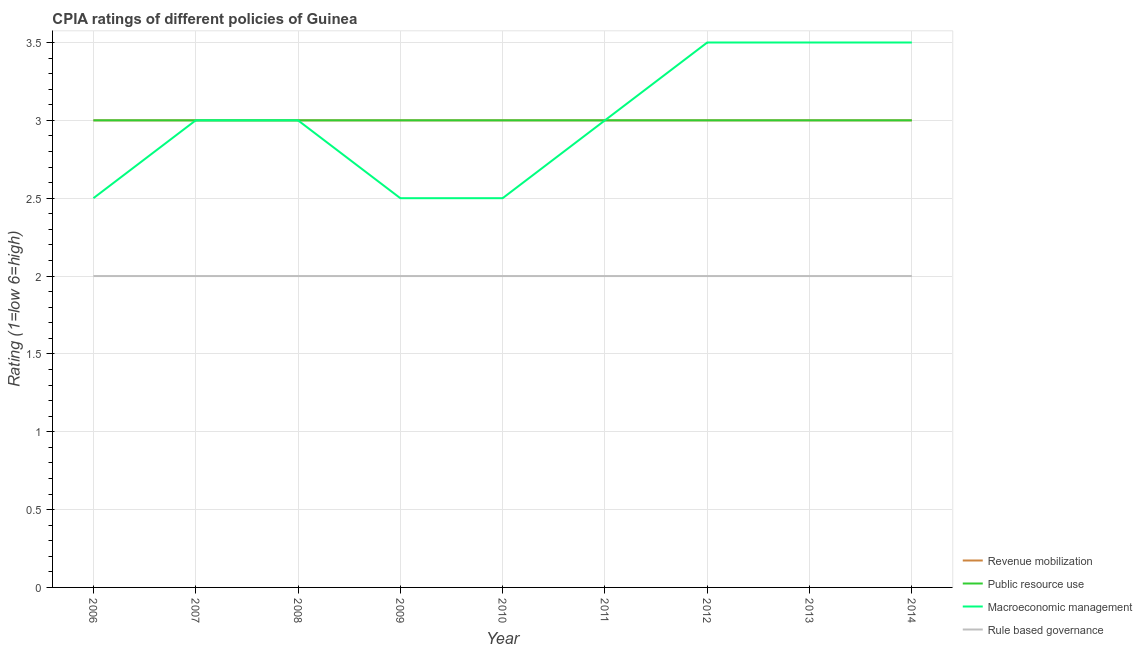Does the line corresponding to cpia rating of revenue mobilization intersect with the line corresponding to cpia rating of macroeconomic management?
Keep it short and to the point. Yes. What is the cpia rating of rule based governance in 2014?
Make the answer very short. 2. Across all years, what is the maximum cpia rating of rule based governance?
Give a very brief answer. 2. Across all years, what is the minimum cpia rating of revenue mobilization?
Make the answer very short. 3. In which year was the cpia rating of public resource use minimum?
Ensure brevity in your answer.  2006. What is the total cpia rating of revenue mobilization in the graph?
Offer a terse response. 27. What is the difference between the cpia rating of rule based governance in 2010 and the cpia rating of public resource use in 2008?
Provide a short and direct response. -1. What is the average cpia rating of rule based governance per year?
Provide a short and direct response. 2. In the year 2013, what is the difference between the cpia rating of macroeconomic management and cpia rating of public resource use?
Ensure brevity in your answer.  0.5. In how many years, is the cpia rating of public resource use greater than 1?
Provide a succinct answer. 9. What is the ratio of the cpia rating of revenue mobilization in 2012 to that in 2014?
Your answer should be very brief. 1. Is the difference between the cpia rating of revenue mobilization in 2011 and 2013 greater than the difference between the cpia rating of public resource use in 2011 and 2013?
Offer a very short reply. No. What is the difference between the highest and the second highest cpia rating of revenue mobilization?
Provide a succinct answer. 0. What is the difference between the highest and the lowest cpia rating of revenue mobilization?
Provide a succinct answer. 0. In how many years, is the cpia rating of macroeconomic management greater than the average cpia rating of macroeconomic management taken over all years?
Offer a very short reply. 3. Is the sum of the cpia rating of macroeconomic management in 2008 and 2010 greater than the maximum cpia rating of public resource use across all years?
Offer a very short reply. Yes. Does the cpia rating of rule based governance monotonically increase over the years?
Your answer should be compact. No. Is the cpia rating of rule based governance strictly greater than the cpia rating of macroeconomic management over the years?
Give a very brief answer. No. Is the cpia rating of revenue mobilization strictly less than the cpia rating of macroeconomic management over the years?
Make the answer very short. No. How many lines are there?
Your answer should be compact. 4. How many years are there in the graph?
Offer a terse response. 9. What is the difference between two consecutive major ticks on the Y-axis?
Offer a terse response. 0.5. Are the values on the major ticks of Y-axis written in scientific E-notation?
Offer a terse response. No. How many legend labels are there?
Keep it short and to the point. 4. How are the legend labels stacked?
Offer a very short reply. Vertical. What is the title of the graph?
Your response must be concise. CPIA ratings of different policies of Guinea. What is the Rating (1=low 6=high) in Revenue mobilization in 2006?
Your answer should be compact. 3. What is the Rating (1=low 6=high) in Rule based governance in 2006?
Your response must be concise. 2. What is the Rating (1=low 6=high) of Public resource use in 2007?
Your answer should be compact. 3. What is the Rating (1=low 6=high) of Rule based governance in 2007?
Your answer should be compact. 2. What is the Rating (1=low 6=high) in Revenue mobilization in 2008?
Make the answer very short. 3. What is the Rating (1=low 6=high) in Macroeconomic management in 2008?
Provide a succinct answer. 3. What is the Rating (1=low 6=high) of Rule based governance in 2008?
Your answer should be very brief. 2. What is the Rating (1=low 6=high) in Revenue mobilization in 2009?
Give a very brief answer. 3. What is the Rating (1=low 6=high) of Public resource use in 2009?
Provide a succinct answer. 3. What is the Rating (1=low 6=high) of Macroeconomic management in 2009?
Offer a very short reply. 2.5. What is the Rating (1=low 6=high) in Public resource use in 2011?
Give a very brief answer. 3. What is the Rating (1=low 6=high) in Rule based governance in 2011?
Make the answer very short. 2. What is the Rating (1=low 6=high) in Revenue mobilization in 2012?
Provide a succinct answer. 3. What is the Rating (1=low 6=high) of Public resource use in 2012?
Give a very brief answer. 3. What is the Rating (1=low 6=high) in Macroeconomic management in 2012?
Your response must be concise. 3.5. What is the Rating (1=low 6=high) of Rule based governance in 2012?
Offer a very short reply. 2. What is the Rating (1=low 6=high) in Revenue mobilization in 2013?
Your answer should be very brief. 3. What is the Rating (1=low 6=high) of Rule based governance in 2013?
Make the answer very short. 2. What is the Rating (1=low 6=high) in Macroeconomic management in 2014?
Offer a terse response. 3.5. What is the Rating (1=low 6=high) in Rule based governance in 2014?
Your answer should be very brief. 2. Across all years, what is the maximum Rating (1=low 6=high) in Public resource use?
Your answer should be compact. 3. Across all years, what is the maximum Rating (1=low 6=high) of Macroeconomic management?
Ensure brevity in your answer.  3.5. Across all years, what is the minimum Rating (1=low 6=high) of Revenue mobilization?
Keep it short and to the point. 3. Across all years, what is the minimum Rating (1=low 6=high) of Public resource use?
Your response must be concise. 3. What is the total Rating (1=low 6=high) in Public resource use in the graph?
Your answer should be very brief. 27. What is the total Rating (1=low 6=high) of Macroeconomic management in the graph?
Offer a very short reply. 27. What is the difference between the Rating (1=low 6=high) in Revenue mobilization in 2006 and that in 2007?
Your answer should be very brief. 0. What is the difference between the Rating (1=low 6=high) in Public resource use in 2006 and that in 2007?
Your response must be concise. 0. What is the difference between the Rating (1=low 6=high) in Rule based governance in 2006 and that in 2007?
Make the answer very short. 0. What is the difference between the Rating (1=low 6=high) in Macroeconomic management in 2006 and that in 2008?
Provide a succinct answer. -0.5. What is the difference between the Rating (1=low 6=high) of Revenue mobilization in 2006 and that in 2009?
Your answer should be very brief. 0. What is the difference between the Rating (1=low 6=high) in Public resource use in 2006 and that in 2009?
Make the answer very short. 0. What is the difference between the Rating (1=low 6=high) of Macroeconomic management in 2006 and that in 2009?
Provide a succinct answer. 0. What is the difference between the Rating (1=low 6=high) of Revenue mobilization in 2006 and that in 2010?
Ensure brevity in your answer.  0. What is the difference between the Rating (1=low 6=high) of Public resource use in 2006 and that in 2010?
Ensure brevity in your answer.  0. What is the difference between the Rating (1=low 6=high) of Macroeconomic management in 2006 and that in 2010?
Provide a short and direct response. 0. What is the difference between the Rating (1=low 6=high) in Rule based governance in 2006 and that in 2010?
Your answer should be compact. 0. What is the difference between the Rating (1=low 6=high) in Macroeconomic management in 2006 and that in 2011?
Your answer should be compact. -0.5. What is the difference between the Rating (1=low 6=high) of Rule based governance in 2006 and that in 2011?
Offer a very short reply. 0. What is the difference between the Rating (1=low 6=high) of Revenue mobilization in 2006 and that in 2012?
Provide a short and direct response. 0. What is the difference between the Rating (1=low 6=high) of Rule based governance in 2006 and that in 2012?
Keep it short and to the point. 0. What is the difference between the Rating (1=low 6=high) in Revenue mobilization in 2006 and that in 2013?
Keep it short and to the point. 0. What is the difference between the Rating (1=low 6=high) in Public resource use in 2006 and that in 2013?
Give a very brief answer. 0. What is the difference between the Rating (1=low 6=high) of Macroeconomic management in 2006 and that in 2013?
Make the answer very short. -1. What is the difference between the Rating (1=low 6=high) of Public resource use in 2006 and that in 2014?
Your answer should be very brief. 0. What is the difference between the Rating (1=low 6=high) in Macroeconomic management in 2006 and that in 2014?
Keep it short and to the point. -1. What is the difference between the Rating (1=low 6=high) in Rule based governance in 2006 and that in 2014?
Ensure brevity in your answer.  0. What is the difference between the Rating (1=low 6=high) of Public resource use in 2007 and that in 2008?
Your answer should be compact. 0. What is the difference between the Rating (1=low 6=high) in Public resource use in 2007 and that in 2009?
Your answer should be compact. 0. What is the difference between the Rating (1=low 6=high) in Macroeconomic management in 2007 and that in 2009?
Your answer should be very brief. 0.5. What is the difference between the Rating (1=low 6=high) in Revenue mobilization in 2007 and that in 2010?
Provide a short and direct response. 0. What is the difference between the Rating (1=low 6=high) of Macroeconomic management in 2007 and that in 2010?
Provide a short and direct response. 0.5. What is the difference between the Rating (1=low 6=high) of Macroeconomic management in 2007 and that in 2011?
Provide a short and direct response. 0. What is the difference between the Rating (1=low 6=high) in Rule based governance in 2007 and that in 2011?
Offer a very short reply. 0. What is the difference between the Rating (1=low 6=high) in Public resource use in 2007 and that in 2012?
Ensure brevity in your answer.  0. What is the difference between the Rating (1=low 6=high) in Rule based governance in 2007 and that in 2012?
Your answer should be compact. 0. What is the difference between the Rating (1=low 6=high) in Macroeconomic management in 2007 and that in 2013?
Your response must be concise. -0.5. What is the difference between the Rating (1=low 6=high) of Rule based governance in 2007 and that in 2013?
Your response must be concise. 0. What is the difference between the Rating (1=low 6=high) in Revenue mobilization in 2007 and that in 2014?
Provide a succinct answer. 0. What is the difference between the Rating (1=low 6=high) in Macroeconomic management in 2007 and that in 2014?
Keep it short and to the point. -0.5. What is the difference between the Rating (1=low 6=high) in Public resource use in 2008 and that in 2010?
Make the answer very short. 0. What is the difference between the Rating (1=low 6=high) in Revenue mobilization in 2008 and that in 2011?
Provide a short and direct response. 0. What is the difference between the Rating (1=low 6=high) of Macroeconomic management in 2008 and that in 2011?
Provide a short and direct response. 0. What is the difference between the Rating (1=low 6=high) in Rule based governance in 2008 and that in 2011?
Make the answer very short. 0. What is the difference between the Rating (1=low 6=high) in Revenue mobilization in 2008 and that in 2012?
Offer a very short reply. 0. What is the difference between the Rating (1=low 6=high) of Macroeconomic management in 2008 and that in 2012?
Keep it short and to the point. -0.5. What is the difference between the Rating (1=low 6=high) of Rule based governance in 2008 and that in 2012?
Keep it short and to the point. 0. What is the difference between the Rating (1=low 6=high) in Revenue mobilization in 2008 and that in 2013?
Your answer should be compact. 0. What is the difference between the Rating (1=low 6=high) in Public resource use in 2008 and that in 2014?
Offer a very short reply. 0. What is the difference between the Rating (1=low 6=high) in Macroeconomic management in 2008 and that in 2014?
Keep it short and to the point. -0.5. What is the difference between the Rating (1=low 6=high) in Rule based governance in 2008 and that in 2014?
Offer a very short reply. 0. What is the difference between the Rating (1=low 6=high) in Revenue mobilization in 2009 and that in 2010?
Keep it short and to the point. 0. What is the difference between the Rating (1=low 6=high) in Macroeconomic management in 2009 and that in 2010?
Your response must be concise. 0. What is the difference between the Rating (1=low 6=high) in Revenue mobilization in 2009 and that in 2011?
Offer a terse response. 0. What is the difference between the Rating (1=low 6=high) of Public resource use in 2009 and that in 2011?
Your answer should be compact. 0. What is the difference between the Rating (1=low 6=high) of Macroeconomic management in 2009 and that in 2011?
Your answer should be compact. -0.5. What is the difference between the Rating (1=low 6=high) of Public resource use in 2009 and that in 2012?
Ensure brevity in your answer.  0. What is the difference between the Rating (1=low 6=high) in Rule based governance in 2009 and that in 2012?
Ensure brevity in your answer.  0. What is the difference between the Rating (1=low 6=high) in Revenue mobilization in 2009 and that in 2013?
Offer a terse response. 0. What is the difference between the Rating (1=low 6=high) of Macroeconomic management in 2009 and that in 2013?
Offer a terse response. -1. What is the difference between the Rating (1=low 6=high) in Rule based governance in 2009 and that in 2013?
Make the answer very short. 0. What is the difference between the Rating (1=low 6=high) in Revenue mobilization in 2009 and that in 2014?
Your answer should be compact. 0. What is the difference between the Rating (1=low 6=high) in Public resource use in 2009 and that in 2014?
Keep it short and to the point. 0. What is the difference between the Rating (1=low 6=high) in Revenue mobilization in 2010 and that in 2011?
Make the answer very short. 0. What is the difference between the Rating (1=low 6=high) in Macroeconomic management in 2010 and that in 2011?
Your response must be concise. -0.5. What is the difference between the Rating (1=low 6=high) in Rule based governance in 2010 and that in 2011?
Your answer should be very brief. 0. What is the difference between the Rating (1=low 6=high) of Macroeconomic management in 2010 and that in 2012?
Your response must be concise. -1. What is the difference between the Rating (1=low 6=high) in Revenue mobilization in 2010 and that in 2013?
Offer a very short reply. 0. What is the difference between the Rating (1=low 6=high) in Macroeconomic management in 2010 and that in 2013?
Your answer should be very brief. -1. What is the difference between the Rating (1=low 6=high) of Rule based governance in 2010 and that in 2013?
Your response must be concise. 0. What is the difference between the Rating (1=low 6=high) of Revenue mobilization in 2010 and that in 2014?
Offer a very short reply. 0. What is the difference between the Rating (1=low 6=high) in Macroeconomic management in 2010 and that in 2014?
Your response must be concise. -1. What is the difference between the Rating (1=low 6=high) of Macroeconomic management in 2011 and that in 2012?
Give a very brief answer. -0.5. What is the difference between the Rating (1=low 6=high) in Rule based governance in 2011 and that in 2012?
Your answer should be very brief. 0. What is the difference between the Rating (1=low 6=high) of Public resource use in 2011 and that in 2013?
Give a very brief answer. 0. What is the difference between the Rating (1=low 6=high) in Rule based governance in 2011 and that in 2013?
Ensure brevity in your answer.  0. What is the difference between the Rating (1=low 6=high) in Revenue mobilization in 2011 and that in 2014?
Make the answer very short. 0. What is the difference between the Rating (1=low 6=high) of Public resource use in 2011 and that in 2014?
Make the answer very short. 0. What is the difference between the Rating (1=low 6=high) in Macroeconomic management in 2011 and that in 2014?
Give a very brief answer. -0.5. What is the difference between the Rating (1=low 6=high) in Rule based governance in 2011 and that in 2014?
Make the answer very short. 0. What is the difference between the Rating (1=low 6=high) in Revenue mobilization in 2012 and that in 2013?
Make the answer very short. 0. What is the difference between the Rating (1=low 6=high) in Public resource use in 2012 and that in 2013?
Provide a succinct answer. 0. What is the difference between the Rating (1=low 6=high) in Macroeconomic management in 2012 and that in 2013?
Provide a short and direct response. 0. What is the difference between the Rating (1=low 6=high) in Revenue mobilization in 2012 and that in 2014?
Ensure brevity in your answer.  0. What is the difference between the Rating (1=low 6=high) of Public resource use in 2012 and that in 2014?
Give a very brief answer. 0. What is the difference between the Rating (1=low 6=high) in Rule based governance in 2012 and that in 2014?
Offer a terse response. 0. What is the difference between the Rating (1=low 6=high) of Revenue mobilization in 2013 and that in 2014?
Offer a terse response. 0. What is the difference between the Rating (1=low 6=high) of Macroeconomic management in 2013 and that in 2014?
Your answer should be compact. 0. What is the difference between the Rating (1=low 6=high) of Rule based governance in 2013 and that in 2014?
Your answer should be very brief. 0. What is the difference between the Rating (1=low 6=high) of Revenue mobilization in 2006 and the Rating (1=low 6=high) of Rule based governance in 2007?
Your answer should be compact. 1. What is the difference between the Rating (1=low 6=high) in Public resource use in 2006 and the Rating (1=low 6=high) in Rule based governance in 2007?
Your answer should be very brief. 1. What is the difference between the Rating (1=low 6=high) of Macroeconomic management in 2006 and the Rating (1=low 6=high) of Rule based governance in 2007?
Your response must be concise. 0.5. What is the difference between the Rating (1=low 6=high) of Revenue mobilization in 2006 and the Rating (1=low 6=high) of Macroeconomic management in 2008?
Ensure brevity in your answer.  0. What is the difference between the Rating (1=low 6=high) in Revenue mobilization in 2006 and the Rating (1=low 6=high) in Rule based governance in 2008?
Provide a short and direct response. 1. What is the difference between the Rating (1=low 6=high) in Public resource use in 2006 and the Rating (1=low 6=high) in Rule based governance in 2008?
Provide a short and direct response. 1. What is the difference between the Rating (1=low 6=high) of Revenue mobilization in 2006 and the Rating (1=low 6=high) of Public resource use in 2009?
Ensure brevity in your answer.  0. What is the difference between the Rating (1=low 6=high) of Revenue mobilization in 2006 and the Rating (1=low 6=high) of Macroeconomic management in 2009?
Provide a succinct answer. 0.5. What is the difference between the Rating (1=low 6=high) of Revenue mobilization in 2006 and the Rating (1=low 6=high) of Rule based governance in 2009?
Provide a succinct answer. 1. What is the difference between the Rating (1=low 6=high) in Public resource use in 2006 and the Rating (1=low 6=high) in Rule based governance in 2009?
Ensure brevity in your answer.  1. What is the difference between the Rating (1=low 6=high) of Revenue mobilization in 2006 and the Rating (1=low 6=high) of Public resource use in 2010?
Make the answer very short. 0. What is the difference between the Rating (1=low 6=high) of Revenue mobilization in 2006 and the Rating (1=low 6=high) of Rule based governance in 2010?
Make the answer very short. 1. What is the difference between the Rating (1=low 6=high) of Macroeconomic management in 2006 and the Rating (1=low 6=high) of Rule based governance in 2010?
Provide a succinct answer. 0.5. What is the difference between the Rating (1=low 6=high) in Revenue mobilization in 2006 and the Rating (1=low 6=high) in Public resource use in 2011?
Your response must be concise. 0. What is the difference between the Rating (1=low 6=high) in Revenue mobilization in 2006 and the Rating (1=low 6=high) in Macroeconomic management in 2011?
Ensure brevity in your answer.  0. What is the difference between the Rating (1=low 6=high) in Public resource use in 2006 and the Rating (1=low 6=high) in Rule based governance in 2011?
Offer a very short reply. 1. What is the difference between the Rating (1=low 6=high) of Macroeconomic management in 2006 and the Rating (1=low 6=high) of Rule based governance in 2011?
Your response must be concise. 0.5. What is the difference between the Rating (1=low 6=high) in Revenue mobilization in 2006 and the Rating (1=low 6=high) in Macroeconomic management in 2012?
Ensure brevity in your answer.  -0.5. What is the difference between the Rating (1=low 6=high) in Revenue mobilization in 2006 and the Rating (1=low 6=high) in Rule based governance in 2012?
Provide a short and direct response. 1. What is the difference between the Rating (1=low 6=high) of Public resource use in 2006 and the Rating (1=low 6=high) of Macroeconomic management in 2012?
Give a very brief answer. -0.5. What is the difference between the Rating (1=low 6=high) of Macroeconomic management in 2006 and the Rating (1=low 6=high) of Rule based governance in 2012?
Ensure brevity in your answer.  0.5. What is the difference between the Rating (1=low 6=high) in Revenue mobilization in 2006 and the Rating (1=low 6=high) in Public resource use in 2013?
Provide a succinct answer. 0. What is the difference between the Rating (1=low 6=high) of Macroeconomic management in 2006 and the Rating (1=low 6=high) of Rule based governance in 2013?
Your answer should be compact. 0.5. What is the difference between the Rating (1=low 6=high) in Revenue mobilization in 2006 and the Rating (1=low 6=high) in Public resource use in 2014?
Make the answer very short. 0. What is the difference between the Rating (1=low 6=high) of Public resource use in 2006 and the Rating (1=low 6=high) of Rule based governance in 2014?
Make the answer very short. 1. What is the difference between the Rating (1=low 6=high) of Revenue mobilization in 2007 and the Rating (1=low 6=high) of Macroeconomic management in 2008?
Give a very brief answer. 0. What is the difference between the Rating (1=low 6=high) of Revenue mobilization in 2007 and the Rating (1=low 6=high) of Rule based governance in 2008?
Make the answer very short. 1. What is the difference between the Rating (1=low 6=high) in Public resource use in 2007 and the Rating (1=low 6=high) in Rule based governance in 2008?
Your answer should be very brief. 1. What is the difference between the Rating (1=low 6=high) in Macroeconomic management in 2007 and the Rating (1=low 6=high) in Rule based governance in 2008?
Give a very brief answer. 1. What is the difference between the Rating (1=low 6=high) in Revenue mobilization in 2007 and the Rating (1=low 6=high) in Rule based governance in 2009?
Provide a short and direct response. 1. What is the difference between the Rating (1=low 6=high) of Public resource use in 2007 and the Rating (1=low 6=high) of Macroeconomic management in 2009?
Give a very brief answer. 0.5. What is the difference between the Rating (1=low 6=high) in Macroeconomic management in 2007 and the Rating (1=low 6=high) in Rule based governance in 2009?
Offer a very short reply. 1. What is the difference between the Rating (1=low 6=high) of Revenue mobilization in 2007 and the Rating (1=low 6=high) of Rule based governance in 2010?
Your answer should be very brief. 1. What is the difference between the Rating (1=low 6=high) of Public resource use in 2007 and the Rating (1=low 6=high) of Macroeconomic management in 2010?
Ensure brevity in your answer.  0.5. What is the difference between the Rating (1=low 6=high) of Public resource use in 2007 and the Rating (1=low 6=high) of Rule based governance in 2010?
Offer a terse response. 1. What is the difference between the Rating (1=low 6=high) in Macroeconomic management in 2007 and the Rating (1=low 6=high) in Rule based governance in 2010?
Your answer should be compact. 1. What is the difference between the Rating (1=low 6=high) of Revenue mobilization in 2007 and the Rating (1=low 6=high) of Public resource use in 2011?
Your answer should be very brief. 0. What is the difference between the Rating (1=low 6=high) in Revenue mobilization in 2007 and the Rating (1=low 6=high) in Macroeconomic management in 2011?
Offer a terse response. 0. What is the difference between the Rating (1=low 6=high) in Macroeconomic management in 2007 and the Rating (1=low 6=high) in Rule based governance in 2011?
Ensure brevity in your answer.  1. What is the difference between the Rating (1=low 6=high) of Public resource use in 2007 and the Rating (1=low 6=high) of Macroeconomic management in 2012?
Ensure brevity in your answer.  -0.5. What is the difference between the Rating (1=low 6=high) in Macroeconomic management in 2007 and the Rating (1=low 6=high) in Rule based governance in 2012?
Offer a very short reply. 1. What is the difference between the Rating (1=low 6=high) of Revenue mobilization in 2007 and the Rating (1=low 6=high) of Macroeconomic management in 2013?
Ensure brevity in your answer.  -0.5. What is the difference between the Rating (1=low 6=high) of Revenue mobilization in 2007 and the Rating (1=low 6=high) of Rule based governance in 2013?
Your answer should be compact. 1. What is the difference between the Rating (1=low 6=high) in Public resource use in 2007 and the Rating (1=low 6=high) in Macroeconomic management in 2013?
Make the answer very short. -0.5. What is the difference between the Rating (1=low 6=high) of Revenue mobilization in 2007 and the Rating (1=low 6=high) of Macroeconomic management in 2014?
Provide a short and direct response. -0.5. What is the difference between the Rating (1=low 6=high) in Revenue mobilization in 2007 and the Rating (1=low 6=high) in Rule based governance in 2014?
Ensure brevity in your answer.  1. What is the difference between the Rating (1=low 6=high) of Public resource use in 2007 and the Rating (1=low 6=high) of Macroeconomic management in 2014?
Offer a terse response. -0.5. What is the difference between the Rating (1=low 6=high) of Revenue mobilization in 2008 and the Rating (1=low 6=high) of Macroeconomic management in 2009?
Provide a succinct answer. 0.5. What is the difference between the Rating (1=low 6=high) in Revenue mobilization in 2008 and the Rating (1=low 6=high) in Rule based governance in 2009?
Ensure brevity in your answer.  1. What is the difference between the Rating (1=low 6=high) of Public resource use in 2008 and the Rating (1=low 6=high) of Rule based governance in 2009?
Keep it short and to the point. 1. What is the difference between the Rating (1=low 6=high) of Macroeconomic management in 2008 and the Rating (1=low 6=high) of Rule based governance in 2009?
Keep it short and to the point. 1. What is the difference between the Rating (1=low 6=high) of Revenue mobilization in 2008 and the Rating (1=low 6=high) of Rule based governance in 2010?
Give a very brief answer. 1. What is the difference between the Rating (1=low 6=high) of Public resource use in 2008 and the Rating (1=low 6=high) of Rule based governance in 2010?
Keep it short and to the point. 1. What is the difference between the Rating (1=low 6=high) in Revenue mobilization in 2008 and the Rating (1=low 6=high) in Public resource use in 2011?
Your response must be concise. 0. What is the difference between the Rating (1=low 6=high) in Revenue mobilization in 2008 and the Rating (1=low 6=high) in Rule based governance in 2011?
Ensure brevity in your answer.  1. What is the difference between the Rating (1=low 6=high) in Public resource use in 2008 and the Rating (1=low 6=high) in Macroeconomic management in 2011?
Make the answer very short. 0. What is the difference between the Rating (1=low 6=high) of Public resource use in 2008 and the Rating (1=low 6=high) of Rule based governance in 2011?
Your answer should be very brief. 1. What is the difference between the Rating (1=low 6=high) in Revenue mobilization in 2008 and the Rating (1=low 6=high) in Public resource use in 2012?
Provide a succinct answer. 0. What is the difference between the Rating (1=low 6=high) in Revenue mobilization in 2008 and the Rating (1=low 6=high) in Macroeconomic management in 2012?
Your response must be concise. -0.5. What is the difference between the Rating (1=low 6=high) in Revenue mobilization in 2008 and the Rating (1=low 6=high) in Rule based governance in 2012?
Your answer should be very brief. 1. What is the difference between the Rating (1=low 6=high) of Public resource use in 2008 and the Rating (1=low 6=high) of Rule based governance in 2012?
Provide a short and direct response. 1. What is the difference between the Rating (1=low 6=high) of Macroeconomic management in 2008 and the Rating (1=low 6=high) of Rule based governance in 2012?
Ensure brevity in your answer.  1. What is the difference between the Rating (1=low 6=high) in Public resource use in 2008 and the Rating (1=low 6=high) in Macroeconomic management in 2013?
Give a very brief answer. -0.5. What is the difference between the Rating (1=low 6=high) in Revenue mobilization in 2008 and the Rating (1=low 6=high) in Macroeconomic management in 2014?
Give a very brief answer. -0.5. What is the difference between the Rating (1=low 6=high) of Public resource use in 2008 and the Rating (1=low 6=high) of Macroeconomic management in 2014?
Your response must be concise. -0.5. What is the difference between the Rating (1=low 6=high) in Public resource use in 2008 and the Rating (1=low 6=high) in Rule based governance in 2014?
Make the answer very short. 1. What is the difference between the Rating (1=low 6=high) in Revenue mobilization in 2009 and the Rating (1=low 6=high) in Public resource use in 2010?
Ensure brevity in your answer.  0. What is the difference between the Rating (1=low 6=high) in Revenue mobilization in 2009 and the Rating (1=low 6=high) in Macroeconomic management in 2010?
Make the answer very short. 0.5. What is the difference between the Rating (1=low 6=high) of Public resource use in 2009 and the Rating (1=low 6=high) of Rule based governance in 2010?
Keep it short and to the point. 1. What is the difference between the Rating (1=low 6=high) in Revenue mobilization in 2009 and the Rating (1=low 6=high) in Public resource use in 2011?
Keep it short and to the point. 0. What is the difference between the Rating (1=low 6=high) in Revenue mobilization in 2009 and the Rating (1=low 6=high) in Macroeconomic management in 2011?
Your answer should be compact. 0. What is the difference between the Rating (1=low 6=high) in Macroeconomic management in 2009 and the Rating (1=low 6=high) in Rule based governance in 2011?
Provide a short and direct response. 0.5. What is the difference between the Rating (1=low 6=high) of Revenue mobilization in 2009 and the Rating (1=low 6=high) of Rule based governance in 2012?
Offer a terse response. 1. What is the difference between the Rating (1=low 6=high) in Macroeconomic management in 2009 and the Rating (1=low 6=high) in Rule based governance in 2012?
Provide a succinct answer. 0.5. What is the difference between the Rating (1=low 6=high) of Revenue mobilization in 2009 and the Rating (1=low 6=high) of Macroeconomic management in 2013?
Offer a terse response. -0.5. What is the difference between the Rating (1=low 6=high) in Revenue mobilization in 2009 and the Rating (1=low 6=high) in Rule based governance in 2013?
Make the answer very short. 1. What is the difference between the Rating (1=low 6=high) of Public resource use in 2009 and the Rating (1=low 6=high) of Macroeconomic management in 2013?
Your answer should be compact. -0.5. What is the difference between the Rating (1=low 6=high) of Public resource use in 2009 and the Rating (1=low 6=high) of Rule based governance in 2013?
Keep it short and to the point. 1. What is the difference between the Rating (1=low 6=high) of Macroeconomic management in 2009 and the Rating (1=low 6=high) of Rule based governance in 2013?
Provide a succinct answer. 0.5. What is the difference between the Rating (1=low 6=high) in Revenue mobilization in 2009 and the Rating (1=low 6=high) in Public resource use in 2014?
Offer a very short reply. 0. What is the difference between the Rating (1=low 6=high) in Revenue mobilization in 2009 and the Rating (1=low 6=high) in Macroeconomic management in 2014?
Your response must be concise. -0.5. What is the difference between the Rating (1=low 6=high) of Revenue mobilization in 2009 and the Rating (1=low 6=high) of Rule based governance in 2014?
Provide a short and direct response. 1. What is the difference between the Rating (1=low 6=high) of Public resource use in 2009 and the Rating (1=low 6=high) of Macroeconomic management in 2014?
Offer a terse response. -0.5. What is the difference between the Rating (1=low 6=high) in Public resource use in 2009 and the Rating (1=low 6=high) in Rule based governance in 2014?
Provide a succinct answer. 1. What is the difference between the Rating (1=low 6=high) in Macroeconomic management in 2009 and the Rating (1=low 6=high) in Rule based governance in 2014?
Keep it short and to the point. 0.5. What is the difference between the Rating (1=low 6=high) of Public resource use in 2010 and the Rating (1=low 6=high) of Rule based governance in 2011?
Offer a terse response. 1. What is the difference between the Rating (1=low 6=high) of Macroeconomic management in 2010 and the Rating (1=low 6=high) of Rule based governance in 2012?
Make the answer very short. 0.5. What is the difference between the Rating (1=low 6=high) of Revenue mobilization in 2010 and the Rating (1=low 6=high) of Macroeconomic management in 2013?
Make the answer very short. -0.5. What is the difference between the Rating (1=low 6=high) of Revenue mobilization in 2010 and the Rating (1=low 6=high) of Rule based governance in 2013?
Offer a terse response. 1. What is the difference between the Rating (1=low 6=high) of Public resource use in 2010 and the Rating (1=low 6=high) of Macroeconomic management in 2013?
Provide a succinct answer. -0.5. What is the difference between the Rating (1=low 6=high) in Public resource use in 2010 and the Rating (1=low 6=high) in Rule based governance in 2013?
Provide a short and direct response. 1. What is the difference between the Rating (1=low 6=high) in Revenue mobilization in 2010 and the Rating (1=low 6=high) in Macroeconomic management in 2014?
Provide a succinct answer. -0.5. What is the difference between the Rating (1=low 6=high) of Revenue mobilization in 2010 and the Rating (1=low 6=high) of Rule based governance in 2014?
Provide a short and direct response. 1. What is the difference between the Rating (1=low 6=high) in Public resource use in 2010 and the Rating (1=low 6=high) in Macroeconomic management in 2014?
Your answer should be compact. -0.5. What is the difference between the Rating (1=low 6=high) of Macroeconomic management in 2010 and the Rating (1=low 6=high) of Rule based governance in 2014?
Offer a terse response. 0.5. What is the difference between the Rating (1=low 6=high) of Revenue mobilization in 2011 and the Rating (1=low 6=high) of Public resource use in 2012?
Your answer should be very brief. 0. What is the difference between the Rating (1=low 6=high) in Revenue mobilization in 2011 and the Rating (1=low 6=high) in Macroeconomic management in 2012?
Offer a very short reply. -0.5. What is the difference between the Rating (1=low 6=high) in Public resource use in 2011 and the Rating (1=low 6=high) in Rule based governance in 2012?
Provide a succinct answer. 1. What is the difference between the Rating (1=low 6=high) of Public resource use in 2011 and the Rating (1=low 6=high) of Macroeconomic management in 2013?
Provide a succinct answer. -0.5. What is the difference between the Rating (1=low 6=high) of Public resource use in 2011 and the Rating (1=low 6=high) of Rule based governance in 2013?
Offer a very short reply. 1. What is the difference between the Rating (1=low 6=high) in Revenue mobilization in 2011 and the Rating (1=low 6=high) in Public resource use in 2014?
Make the answer very short. 0. What is the difference between the Rating (1=low 6=high) in Revenue mobilization in 2011 and the Rating (1=low 6=high) in Rule based governance in 2014?
Your response must be concise. 1. What is the difference between the Rating (1=low 6=high) of Public resource use in 2011 and the Rating (1=low 6=high) of Macroeconomic management in 2014?
Your answer should be compact. -0.5. What is the difference between the Rating (1=low 6=high) of Macroeconomic management in 2011 and the Rating (1=low 6=high) of Rule based governance in 2014?
Give a very brief answer. 1. What is the difference between the Rating (1=low 6=high) in Revenue mobilization in 2012 and the Rating (1=low 6=high) in Public resource use in 2013?
Provide a succinct answer. 0. What is the difference between the Rating (1=low 6=high) of Revenue mobilization in 2012 and the Rating (1=low 6=high) of Macroeconomic management in 2013?
Make the answer very short. -0.5. What is the difference between the Rating (1=low 6=high) of Macroeconomic management in 2012 and the Rating (1=low 6=high) of Rule based governance in 2014?
Ensure brevity in your answer.  1.5. What is the difference between the Rating (1=low 6=high) of Revenue mobilization in 2013 and the Rating (1=low 6=high) of Macroeconomic management in 2014?
Your answer should be compact. -0.5. What is the difference between the Rating (1=low 6=high) in Revenue mobilization in 2013 and the Rating (1=low 6=high) in Rule based governance in 2014?
Give a very brief answer. 1. What is the difference between the Rating (1=low 6=high) in Macroeconomic management in 2013 and the Rating (1=low 6=high) in Rule based governance in 2014?
Make the answer very short. 1.5. What is the average Rating (1=low 6=high) in Rule based governance per year?
Give a very brief answer. 2. In the year 2006, what is the difference between the Rating (1=low 6=high) of Revenue mobilization and Rating (1=low 6=high) of Rule based governance?
Offer a terse response. 1. In the year 2006, what is the difference between the Rating (1=low 6=high) in Public resource use and Rating (1=low 6=high) in Macroeconomic management?
Offer a terse response. 0.5. In the year 2007, what is the difference between the Rating (1=low 6=high) of Revenue mobilization and Rating (1=low 6=high) of Public resource use?
Give a very brief answer. 0. In the year 2007, what is the difference between the Rating (1=low 6=high) of Revenue mobilization and Rating (1=low 6=high) of Rule based governance?
Your response must be concise. 1. In the year 2007, what is the difference between the Rating (1=low 6=high) in Public resource use and Rating (1=low 6=high) in Rule based governance?
Make the answer very short. 1. In the year 2008, what is the difference between the Rating (1=low 6=high) in Revenue mobilization and Rating (1=low 6=high) in Macroeconomic management?
Offer a very short reply. 0. In the year 2008, what is the difference between the Rating (1=low 6=high) of Revenue mobilization and Rating (1=low 6=high) of Rule based governance?
Offer a very short reply. 1. In the year 2008, what is the difference between the Rating (1=low 6=high) in Macroeconomic management and Rating (1=low 6=high) in Rule based governance?
Offer a very short reply. 1. In the year 2009, what is the difference between the Rating (1=low 6=high) in Revenue mobilization and Rating (1=low 6=high) in Macroeconomic management?
Provide a short and direct response. 0.5. In the year 2010, what is the difference between the Rating (1=low 6=high) in Revenue mobilization and Rating (1=low 6=high) in Public resource use?
Make the answer very short. 0. In the year 2010, what is the difference between the Rating (1=low 6=high) of Revenue mobilization and Rating (1=low 6=high) of Macroeconomic management?
Provide a succinct answer. 0.5. In the year 2010, what is the difference between the Rating (1=low 6=high) in Revenue mobilization and Rating (1=low 6=high) in Rule based governance?
Give a very brief answer. 1. In the year 2010, what is the difference between the Rating (1=low 6=high) of Public resource use and Rating (1=low 6=high) of Macroeconomic management?
Offer a terse response. 0.5. In the year 2011, what is the difference between the Rating (1=low 6=high) of Revenue mobilization and Rating (1=low 6=high) of Public resource use?
Your response must be concise. 0. In the year 2011, what is the difference between the Rating (1=low 6=high) of Revenue mobilization and Rating (1=low 6=high) of Macroeconomic management?
Offer a terse response. 0. In the year 2011, what is the difference between the Rating (1=low 6=high) in Public resource use and Rating (1=low 6=high) in Macroeconomic management?
Offer a very short reply. 0. In the year 2011, what is the difference between the Rating (1=low 6=high) in Public resource use and Rating (1=low 6=high) in Rule based governance?
Make the answer very short. 1. In the year 2011, what is the difference between the Rating (1=low 6=high) of Macroeconomic management and Rating (1=low 6=high) of Rule based governance?
Your answer should be very brief. 1. In the year 2012, what is the difference between the Rating (1=low 6=high) in Revenue mobilization and Rating (1=low 6=high) in Public resource use?
Provide a short and direct response. 0. In the year 2012, what is the difference between the Rating (1=low 6=high) of Revenue mobilization and Rating (1=low 6=high) of Macroeconomic management?
Provide a succinct answer. -0.5. In the year 2012, what is the difference between the Rating (1=low 6=high) of Public resource use and Rating (1=low 6=high) of Rule based governance?
Give a very brief answer. 1. In the year 2013, what is the difference between the Rating (1=low 6=high) in Revenue mobilization and Rating (1=low 6=high) in Macroeconomic management?
Your answer should be very brief. -0.5. In the year 2013, what is the difference between the Rating (1=low 6=high) in Public resource use and Rating (1=low 6=high) in Macroeconomic management?
Offer a very short reply. -0.5. In the year 2013, what is the difference between the Rating (1=low 6=high) in Public resource use and Rating (1=low 6=high) in Rule based governance?
Your answer should be very brief. 1. In the year 2013, what is the difference between the Rating (1=low 6=high) in Macroeconomic management and Rating (1=low 6=high) in Rule based governance?
Keep it short and to the point. 1.5. In the year 2014, what is the difference between the Rating (1=low 6=high) in Macroeconomic management and Rating (1=low 6=high) in Rule based governance?
Make the answer very short. 1.5. What is the ratio of the Rating (1=low 6=high) of Public resource use in 2006 to that in 2007?
Offer a very short reply. 1. What is the ratio of the Rating (1=low 6=high) of Macroeconomic management in 2006 to that in 2007?
Provide a short and direct response. 0.83. What is the ratio of the Rating (1=low 6=high) in Rule based governance in 2006 to that in 2007?
Keep it short and to the point. 1. What is the ratio of the Rating (1=low 6=high) of Revenue mobilization in 2006 to that in 2008?
Offer a very short reply. 1. What is the ratio of the Rating (1=low 6=high) of Macroeconomic management in 2006 to that in 2008?
Make the answer very short. 0.83. What is the ratio of the Rating (1=low 6=high) in Rule based governance in 2006 to that in 2008?
Your answer should be compact. 1. What is the ratio of the Rating (1=low 6=high) of Macroeconomic management in 2006 to that in 2009?
Your answer should be very brief. 1. What is the ratio of the Rating (1=low 6=high) of Revenue mobilization in 2006 to that in 2010?
Provide a short and direct response. 1. What is the ratio of the Rating (1=low 6=high) of Macroeconomic management in 2006 to that in 2010?
Your answer should be very brief. 1. What is the ratio of the Rating (1=low 6=high) of Rule based governance in 2006 to that in 2010?
Your answer should be compact. 1. What is the ratio of the Rating (1=low 6=high) of Revenue mobilization in 2006 to that in 2011?
Make the answer very short. 1. What is the ratio of the Rating (1=low 6=high) of Macroeconomic management in 2006 to that in 2011?
Provide a succinct answer. 0.83. What is the ratio of the Rating (1=low 6=high) of Rule based governance in 2006 to that in 2011?
Provide a succinct answer. 1. What is the ratio of the Rating (1=low 6=high) of Revenue mobilization in 2006 to that in 2012?
Provide a succinct answer. 1. What is the ratio of the Rating (1=low 6=high) of Macroeconomic management in 2006 to that in 2012?
Your answer should be compact. 0.71. What is the ratio of the Rating (1=low 6=high) in Rule based governance in 2006 to that in 2012?
Keep it short and to the point. 1. What is the ratio of the Rating (1=low 6=high) of Public resource use in 2006 to that in 2013?
Offer a terse response. 1. What is the ratio of the Rating (1=low 6=high) of Macroeconomic management in 2006 to that in 2013?
Your answer should be very brief. 0.71. What is the ratio of the Rating (1=low 6=high) in Revenue mobilization in 2006 to that in 2014?
Your answer should be compact. 1. What is the ratio of the Rating (1=low 6=high) of Macroeconomic management in 2007 to that in 2008?
Offer a terse response. 1. What is the ratio of the Rating (1=low 6=high) in Revenue mobilization in 2007 to that in 2009?
Provide a succinct answer. 1. What is the ratio of the Rating (1=low 6=high) in Public resource use in 2007 to that in 2009?
Offer a terse response. 1. What is the ratio of the Rating (1=low 6=high) of Macroeconomic management in 2007 to that in 2010?
Make the answer very short. 1.2. What is the ratio of the Rating (1=low 6=high) in Rule based governance in 2007 to that in 2010?
Make the answer very short. 1. What is the ratio of the Rating (1=low 6=high) in Public resource use in 2007 to that in 2011?
Offer a very short reply. 1. What is the ratio of the Rating (1=low 6=high) of Public resource use in 2007 to that in 2012?
Your answer should be very brief. 1. What is the ratio of the Rating (1=low 6=high) of Rule based governance in 2007 to that in 2012?
Provide a short and direct response. 1. What is the ratio of the Rating (1=low 6=high) in Public resource use in 2007 to that in 2013?
Provide a succinct answer. 1. What is the ratio of the Rating (1=low 6=high) in Macroeconomic management in 2007 to that in 2013?
Your answer should be very brief. 0.86. What is the ratio of the Rating (1=low 6=high) of Revenue mobilization in 2007 to that in 2014?
Provide a succinct answer. 1. What is the ratio of the Rating (1=low 6=high) of Revenue mobilization in 2008 to that in 2009?
Make the answer very short. 1. What is the ratio of the Rating (1=low 6=high) in Public resource use in 2008 to that in 2009?
Ensure brevity in your answer.  1. What is the ratio of the Rating (1=low 6=high) of Macroeconomic management in 2008 to that in 2009?
Provide a succinct answer. 1.2. What is the ratio of the Rating (1=low 6=high) of Revenue mobilization in 2008 to that in 2010?
Your answer should be compact. 1. What is the ratio of the Rating (1=low 6=high) of Revenue mobilization in 2008 to that in 2011?
Offer a terse response. 1. What is the ratio of the Rating (1=low 6=high) in Public resource use in 2008 to that in 2011?
Keep it short and to the point. 1. What is the ratio of the Rating (1=low 6=high) in Macroeconomic management in 2008 to that in 2011?
Provide a short and direct response. 1. What is the ratio of the Rating (1=low 6=high) in Rule based governance in 2008 to that in 2011?
Give a very brief answer. 1. What is the ratio of the Rating (1=low 6=high) of Revenue mobilization in 2008 to that in 2012?
Make the answer very short. 1. What is the ratio of the Rating (1=low 6=high) of Public resource use in 2008 to that in 2012?
Your answer should be compact. 1. What is the ratio of the Rating (1=low 6=high) of Macroeconomic management in 2008 to that in 2012?
Provide a short and direct response. 0.86. What is the ratio of the Rating (1=low 6=high) of Rule based governance in 2008 to that in 2012?
Provide a short and direct response. 1. What is the ratio of the Rating (1=low 6=high) in Public resource use in 2008 to that in 2013?
Ensure brevity in your answer.  1. What is the ratio of the Rating (1=low 6=high) in Macroeconomic management in 2008 to that in 2013?
Your response must be concise. 0.86. What is the ratio of the Rating (1=low 6=high) of Rule based governance in 2008 to that in 2013?
Your answer should be compact. 1. What is the ratio of the Rating (1=low 6=high) in Revenue mobilization in 2008 to that in 2014?
Make the answer very short. 1. What is the ratio of the Rating (1=low 6=high) in Public resource use in 2008 to that in 2014?
Give a very brief answer. 1. What is the ratio of the Rating (1=low 6=high) in Revenue mobilization in 2009 to that in 2010?
Your response must be concise. 1. What is the ratio of the Rating (1=low 6=high) of Macroeconomic management in 2009 to that in 2011?
Your answer should be very brief. 0.83. What is the ratio of the Rating (1=low 6=high) of Rule based governance in 2009 to that in 2011?
Give a very brief answer. 1. What is the ratio of the Rating (1=low 6=high) in Public resource use in 2009 to that in 2012?
Give a very brief answer. 1. What is the ratio of the Rating (1=low 6=high) in Macroeconomic management in 2009 to that in 2012?
Ensure brevity in your answer.  0.71. What is the ratio of the Rating (1=low 6=high) of Rule based governance in 2009 to that in 2012?
Ensure brevity in your answer.  1. What is the ratio of the Rating (1=low 6=high) in Revenue mobilization in 2009 to that in 2014?
Your answer should be very brief. 1. What is the ratio of the Rating (1=low 6=high) in Public resource use in 2009 to that in 2014?
Keep it short and to the point. 1. What is the ratio of the Rating (1=low 6=high) in Revenue mobilization in 2010 to that in 2011?
Provide a short and direct response. 1. What is the ratio of the Rating (1=low 6=high) in Public resource use in 2010 to that in 2011?
Give a very brief answer. 1. What is the ratio of the Rating (1=low 6=high) in Revenue mobilization in 2010 to that in 2012?
Your answer should be compact. 1. What is the ratio of the Rating (1=low 6=high) of Public resource use in 2010 to that in 2013?
Offer a very short reply. 1. What is the ratio of the Rating (1=low 6=high) of Revenue mobilization in 2010 to that in 2014?
Your answer should be compact. 1. What is the ratio of the Rating (1=low 6=high) in Rule based governance in 2010 to that in 2014?
Offer a terse response. 1. What is the ratio of the Rating (1=low 6=high) of Revenue mobilization in 2011 to that in 2012?
Offer a terse response. 1. What is the ratio of the Rating (1=low 6=high) in Public resource use in 2011 to that in 2012?
Make the answer very short. 1. What is the ratio of the Rating (1=low 6=high) in Macroeconomic management in 2011 to that in 2012?
Offer a very short reply. 0.86. What is the ratio of the Rating (1=low 6=high) in Revenue mobilization in 2011 to that in 2013?
Your answer should be compact. 1. What is the ratio of the Rating (1=low 6=high) of Macroeconomic management in 2011 to that in 2013?
Offer a very short reply. 0.86. What is the ratio of the Rating (1=low 6=high) in Rule based governance in 2011 to that in 2013?
Make the answer very short. 1. What is the ratio of the Rating (1=low 6=high) of Macroeconomic management in 2011 to that in 2014?
Your answer should be compact. 0.86. What is the ratio of the Rating (1=low 6=high) of Rule based governance in 2011 to that in 2014?
Your response must be concise. 1. What is the ratio of the Rating (1=low 6=high) of Revenue mobilization in 2012 to that in 2013?
Offer a very short reply. 1. What is the ratio of the Rating (1=low 6=high) in Public resource use in 2012 to that in 2013?
Ensure brevity in your answer.  1. What is the ratio of the Rating (1=low 6=high) of Macroeconomic management in 2012 to that in 2013?
Provide a succinct answer. 1. What is the ratio of the Rating (1=low 6=high) in Rule based governance in 2012 to that in 2013?
Your answer should be very brief. 1. What is the ratio of the Rating (1=low 6=high) in Rule based governance in 2012 to that in 2014?
Give a very brief answer. 1. What is the difference between the highest and the second highest Rating (1=low 6=high) in Revenue mobilization?
Provide a succinct answer. 0. What is the difference between the highest and the second highest Rating (1=low 6=high) of Macroeconomic management?
Ensure brevity in your answer.  0. What is the difference between the highest and the lowest Rating (1=low 6=high) in Revenue mobilization?
Keep it short and to the point. 0. What is the difference between the highest and the lowest Rating (1=low 6=high) of Macroeconomic management?
Your response must be concise. 1. 